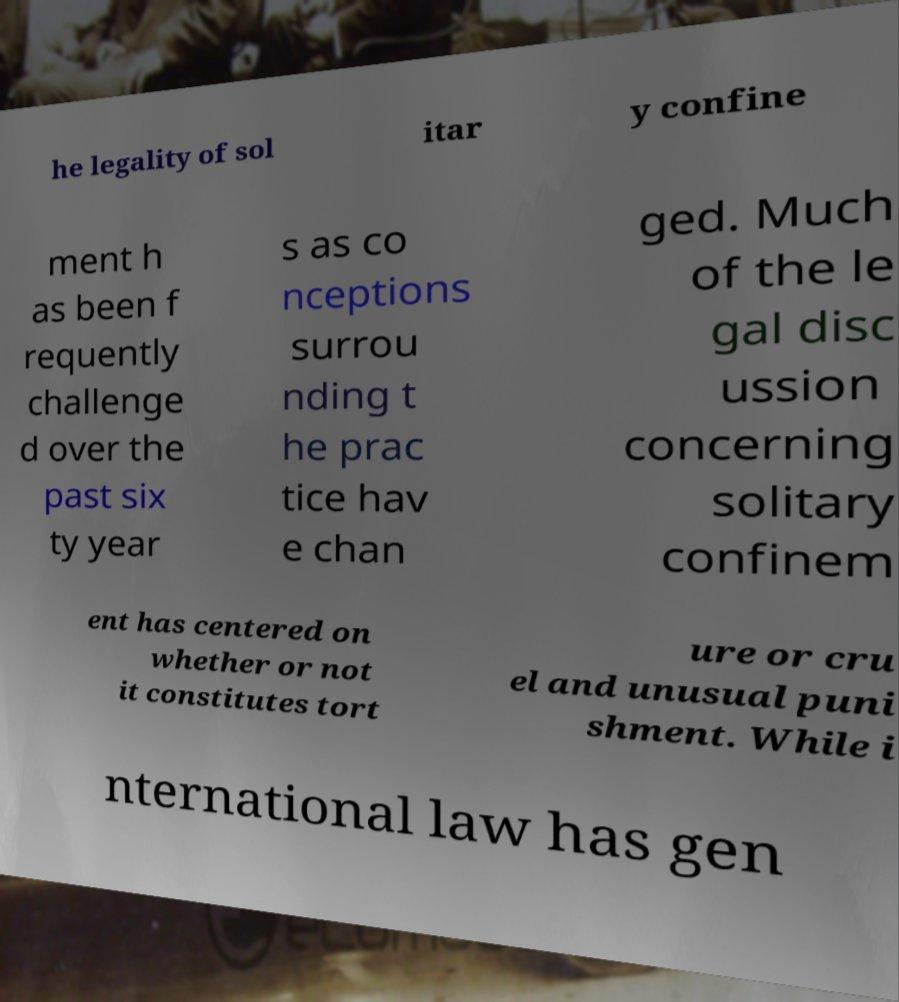Can you accurately transcribe the text from the provided image for me? he legality of sol itar y confine ment h as been f requently challenge d over the past six ty year s as co nceptions surrou nding t he prac tice hav e chan ged. Much of the le gal disc ussion concerning solitary confinem ent has centered on whether or not it constitutes tort ure or cru el and unusual puni shment. While i nternational law has gen 